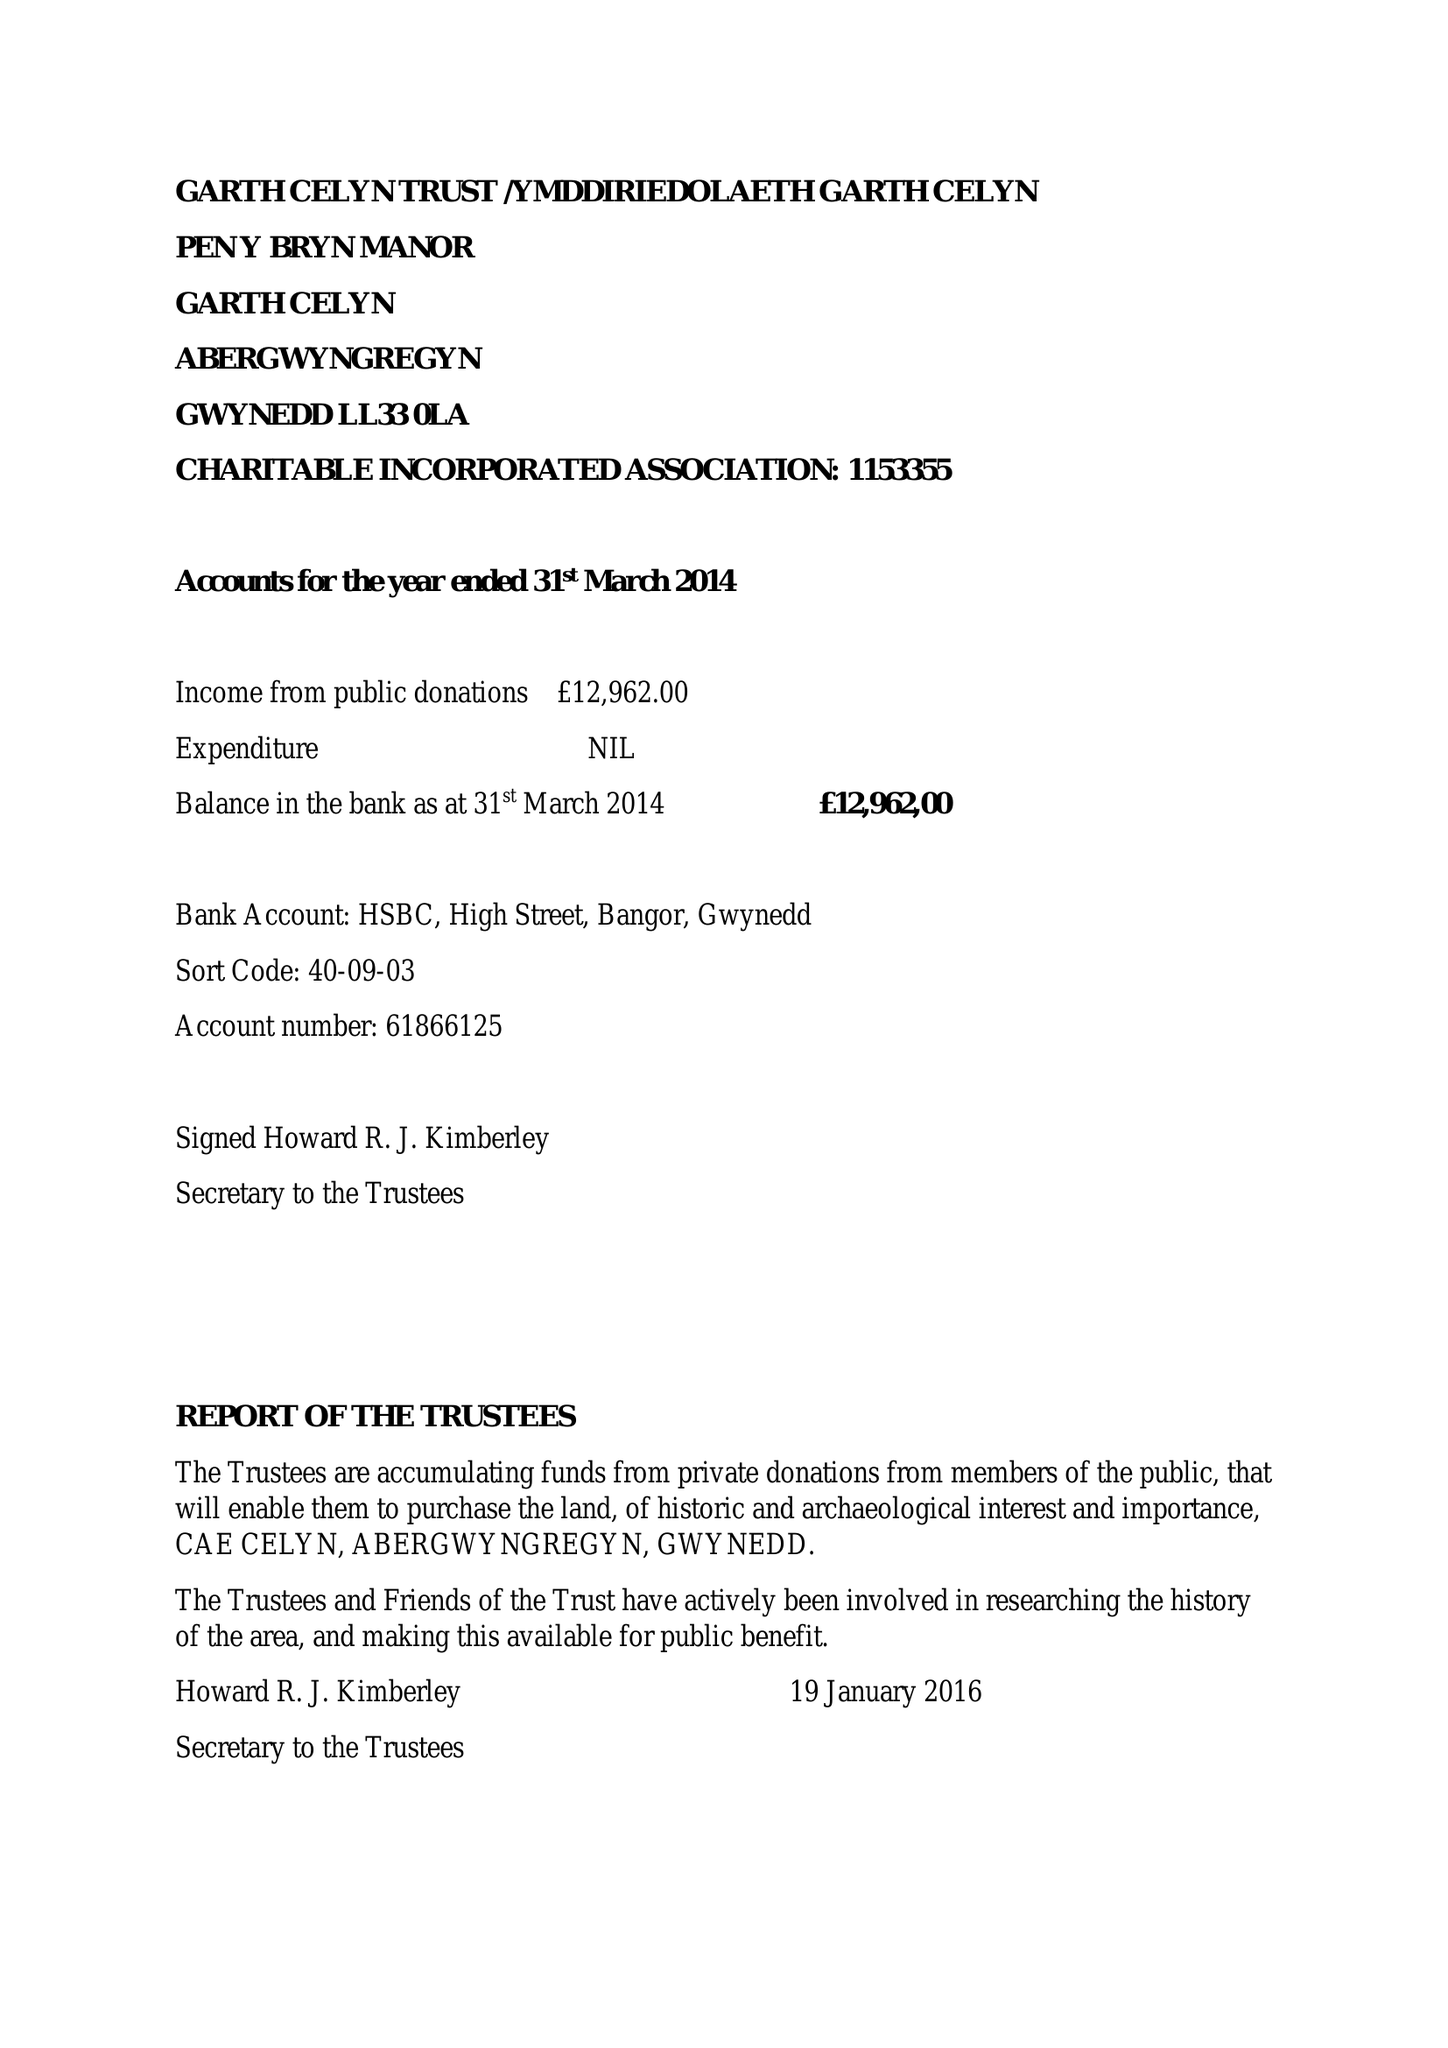What is the value for the spending_annually_in_british_pounds?
Answer the question using a single word or phrase. 1200.00 